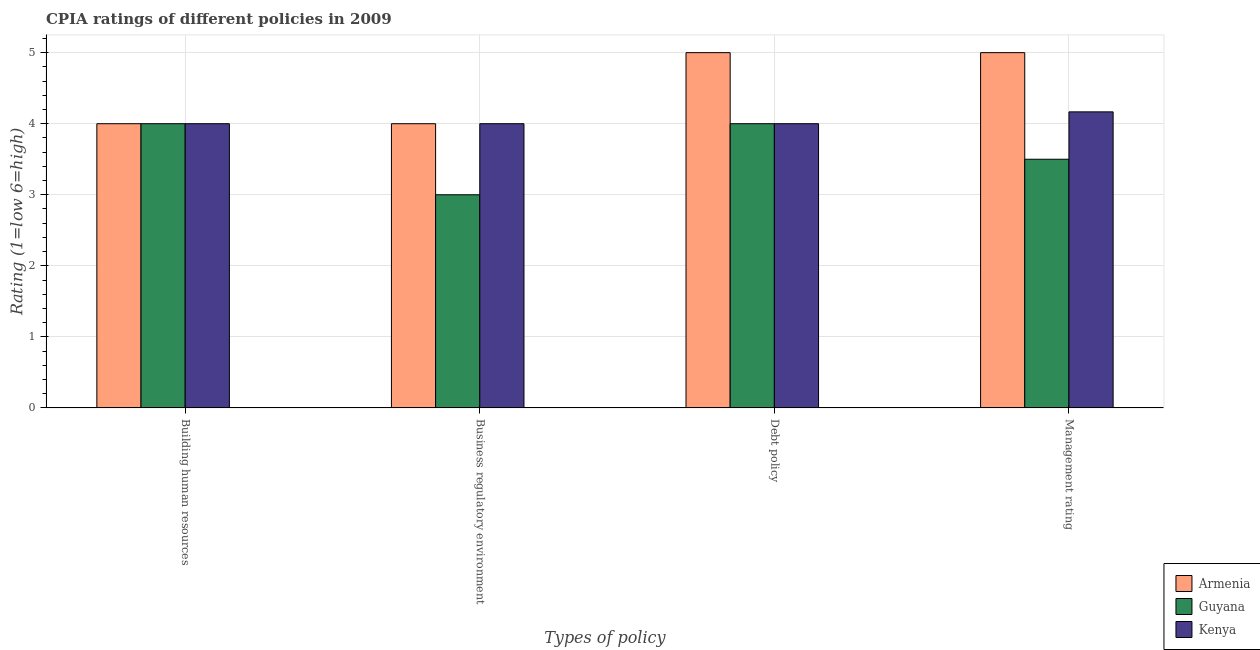How many groups of bars are there?
Ensure brevity in your answer.  4. What is the label of the 2nd group of bars from the left?
Your response must be concise. Business regulatory environment. What is the cpia rating of debt policy in Armenia?
Your response must be concise. 5. Across all countries, what is the maximum cpia rating of debt policy?
Offer a terse response. 5. Across all countries, what is the minimum cpia rating of management?
Give a very brief answer. 3.5. In which country was the cpia rating of business regulatory environment maximum?
Keep it short and to the point. Armenia. In which country was the cpia rating of building human resources minimum?
Your answer should be very brief. Armenia. What is the total cpia rating of management in the graph?
Keep it short and to the point. 12.67. What is the difference between the cpia rating of debt policy in Kenya and that in Armenia?
Ensure brevity in your answer.  -1. What is the difference between the cpia rating of management in Kenya and the cpia rating of debt policy in Guyana?
Make the answer very short. 0.17. What is the average cpia rating of management per country?
Offer a very short reply. 4.22. In how many countries, is the cpia rating of management greater than 3.6 ?
Offer a terse response. 2. What is the ratio of the cpia rating of management in Kenya to that in Armenia?
Your response must be concise. 0.83. Is the cpia rating of management in Guyana less than that in Kenya?
Provide a succinct answer. Yes. What is the difference between the highest and the second highest cpia rating of building human resources?
Provide a short and direct response. 0. What is the difference between the highest and the lowest cpia rating of business regulatory environment?
Your answer should be compact. 1. In how many countries, is the cpia rating of management greater than the average cpia rating of management taken over all countries?
Offer a very short reply. 1. Is the sum of the cpia rating of management in Guyana and Kenya greater than the maximum cpia rating of business regulatory environment across all countries?
Offer a very short reply. Yes. Is it the case that in every country, the sum of the cpia rating of debt policy and cpia rating of management is greater than the sum of cpia rating of business regulatory environment and cpia rating of building human resources?
Offer a terse response. Yes. What does the 3rd bar from the left in Management rating represents?
Ensure brevity in your answer.  Kenya. What does the 1st bar from the right in Building human resources represents?
Your response must be concise. Kenya. Are all the bars in the graph horizontal?
Keep it short and to the point. No. How many countries are there in the graph?
Keep it short and to the point. 3. Does the graph contain grids?
Your answer should be compact. Yes. Where does the legend appear in the graph?
Provide a succinct answer. Bottom right. How are the legend labels stacked?
Make the answer very short. Vertical. What is the title of the graph?
Make the answer very short. CPIA ratings of different policies in 2009. What is the label or title of the X-axis?
Your answer should be very brief. Types of policy. What is the Rating (1=low 6=high) of Armenia in Building human resources?
Your response must be concise. 4. What is the Rating (1=low 6=high) of Armenia in Business regulatory environment?
Your answer should be compact. 4. What is the Rating (1=low 6=high) in Kenya in Debt policy?
Ensure brevity in your answer.  4. What is the Rating (1=low 6=high) in Armenia in Management rating?
Offer a terse response. 5. What is the Rating (1=low 6=high) of Guyana in Management rating?
Provide a succinct answer. 3.5. What is the Rating (1=low 6=high) of Kenya in Management rating?
Your answer should be compact. 4.17. Across all Types of policy, what is the maximum Rating (1=low 6=high) in Kenya?
Keep it short and to the point. 4.17. Across all Types of policy, what is the minimum Rating (1=low 6=high) in Armenia?
Offer a terse response. 4. Across all Types of policy, what is the minimum Rating (1=low 6=high) of Guyana?
Your answer should be very brief. 3. Across all Types of policy, what is the minimum Rating (1=low 6=high) in Kenya?
Provide a succinct answer. 4. What is the total Rating (1=low 6=high) in Armenia in the graph?
Make the answer very short. 18. What is the total Rating (1=low 6=high) in Kenya in the graph?
Keep it short and to the point. 16.17. What is the difference between the Rating (1=low 6=high) of Guyana in Building human resources and that in Business regulatory environment?
Your answer should be compact. 1. What is the difference between the Rating (1=low 6=high) in Kenya in Building human resources and that in Business regulatory environment?
Provide a short and direct response. 0. What is the difference between the Rating (1=low 6=high) in Armenia in Building human resources and that in Debt policy?
Keep it short and to the point. -1. What is the difference between the Rating (1=low 6=high) in Guyana in Building human resources and that in Debt policy?
Your answer should be very brief. 0. What is the difference between the Rating (1=low 6=high) of Kenya in Building human resources and that in Debt policy?
Provide a succinct answer. 0. What is the difference between the Rating (1=low 6=high) of Armenia in Building human resources and that in Management rating?
Offer a terse response. -1. What is the difference between the Rating (1=low 6=high) in Guyana in Building human resources and that in Management rating?
Provide a succinct answer. 0.5. What is the difference between the Rating (1=low 6=high) in Kenya in Building human resources and that in Management rating?
Offer a terse response. -0.17. What is the difference between the Rating (1=low 6=high) in Guyana in Business regulatory environment and that in Management rating?
Provide a succinct answer. -0.5. What is the difference between the Rating (1=low 6=high) in Armenia in Building human resources and the Rating (1=low 6=high) in Guyana in Business regulatory environment?
Give a very brief answer. 1. What is the difference between the Rating (1=low 6=high) of Armenia in Building human resources and the Rating (1=low 6=high) of Kenya in Business regulatory environment?
Offer a terse response. 0. What is the difference between the Rating (1=low 6=high) in Guyana in Building human resources and the Rating (1=low 6=high) in Kenya in Business regulatory environment?
Your answer should be compact. 0. What is the difference between the Rating (1=low 6=high) in Armenia in Building human resources and the Rating (1=low 6=high) in Guyana in Debt policy?
Make the answer very short. 0. What is the difference between the Rating (1=low 6=high) of Armenia in Building human resources and the Rating (1=low 6=high) of Kenya in Debt policy?
Give a very brief answer. 0. What is the difference between the Rating (1=low 6=high) in Armenia in Building human resources and the Rating (1=low 6=high) in Kenya in Management rating?
Make the answer very short. -0.17. What is the difference between the Rating (1=low 6=high) in Armenia in Business regulatory environment and the Rating (1=low 6=high) in Kenya in Debt policy?
Offer a very short reply. 0. What is the difference between the Rating (1=low 6=high) in Armenia in Business regulatory environment and the Rating (1=low 6=high) in Kenya in Management rating?
Offer a very short reply. -0.17. What is the difference between the Rating (1=low 6=high) in Guyana in Business regulatory environment and the Rating (1=low 6=high) in Kenya in Management rating?
Provide a short and direct response. -1.17. What is the difference between the Rating (1=low 6=high) of Armenia in Debt policy and the Rating (1=low 6=high) of Guyana in Management rating?
Make the answer very short. 1.5. What is the difference between the Rating (1=low 6=high) of Armenia in Debt policy and the Rating (1=low 6=high) of Kenya in Management rating?
Ensure brevity in your answer.  0.83. What is the average Rating (1=low 6=high) in Armenia per Types of policy?
Ensure brevity in your answer.  4.5. What is the average Rating (1=low 6=high) in Guyana per Types of policy?
Provide a succinct answer. 3.62. What is the average Rating (1=low 6=high) in Kenya per Types of policy?
Keep it short and to the point. 4.04. What is the difference between the Rating (1=low 6=high) of Armenia and Rating (1=low 6=high) of Kenya in Building human resources?
Keep it short and to the point. 0. What is the difference between the Rating (1=low 6=high) in Guyana and Rating (1=low 6=high) in Kenya in Building human resources?
Provide a succinct answer. 0. What is the difference between the Rating (1=low 6=high) in Armenia and Rating (1=low 6=high) in Guyana in Business regulatory environment?
Provide a succinct answer. 1. What is the difference between the Rating (1=low 6=high) in Guyana and Rating (1=low 6=high) in Kenya in Business regulatory environment?
Keep it short and to the point. -1. What is the difference between the Rating (1=low 6=high) in Guyana and Rating (1=low 6=high) in Kenya in Debt policy?
Your answer should be compact. 0. What is the difference between the Rating (1=low 6=high) in Guyana and Rating (1=low 6=high) in Kenya in Management rating?
Provide a short and direct response. -0.67. What is the ratio of the Rating (1=low 6=high) in Guyana in Building human resources to that in Business regulatory environment?
Your answer should be compact. 1.33. What is the ratio of the Rating (1=low 6=high) of Armenia in Building human resources to that in Debt policy?
Offer a terse response. 0.8. What is the ratio of the Rating (1=low 6=high) in Kenya in Building human resources to that in Debt policy?
Offer a very short reply. 1. What is the ratio of the Rating (1=low 6=high) in Kenya in Building human resources to that in Management rating?
Offer a terse response. 0.96. What is the ratio of the Rating (1=low 6=high) of Kenya in Business regulatory environment to that in Debt policy?
Keep it short and to the point. 1. What is the ratio of the Rating (1=low 6=high) of Armenia in Business regulatory environment to that in Management rating?
Provide a short and direct response. 0.8. What is the ratio of the Rating (1=low 6=high) in Guyana in Business regulatory environment to that in Management rating?
Keep it short and to the point. 0.86. What is the ratio of the Rating (1=low 6=high) of Kenya in Business regulatory environment to that in Management rating?
Keep it short and to the point. 0.96. What is the ratio of the Rating (1=low 6=high) of Guyana in Debt policy to that in Management rating?
Ensure brevity in your answer.  1.14. What is the ratio of the Rating (1=low 6=high) in Kenya in Debt policy to that in Management rating?
Give a very brief answer. 0.96. What is the difference between the highest and the lowest Rating (1=low 6=high) of Guyana?
Provide a short and direct response. 1. 